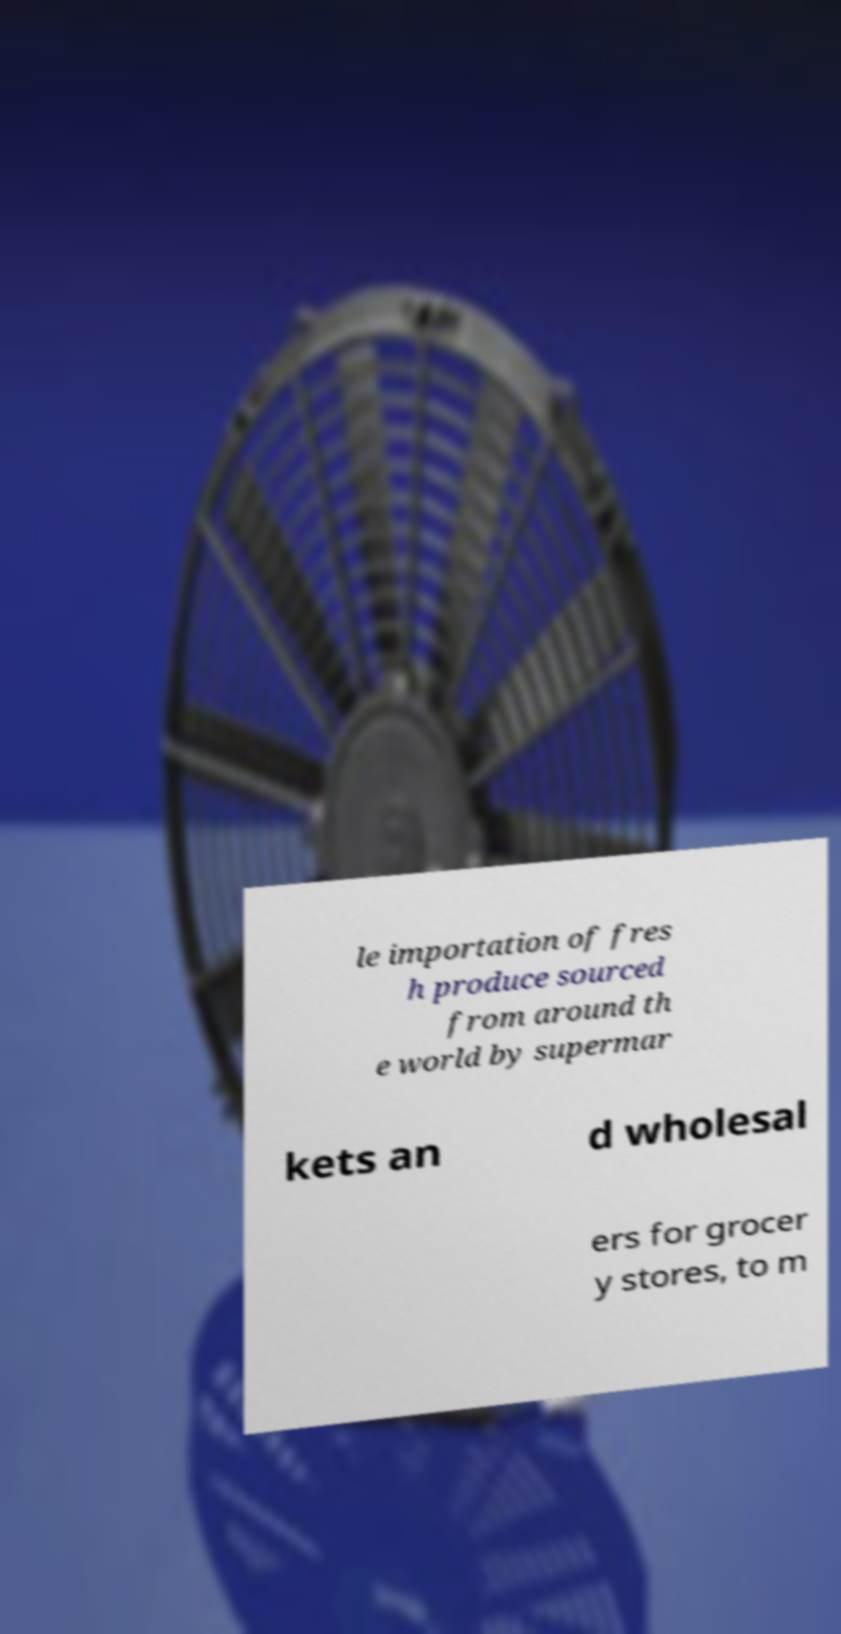Can you read and provide the text displayed in the image?This photo seems to have some interesting text. Can you extract and type it out for me? le importation of fres h produce sourced from around th e world by supermar kets an d wholesal ers for grocer y stores, to m 